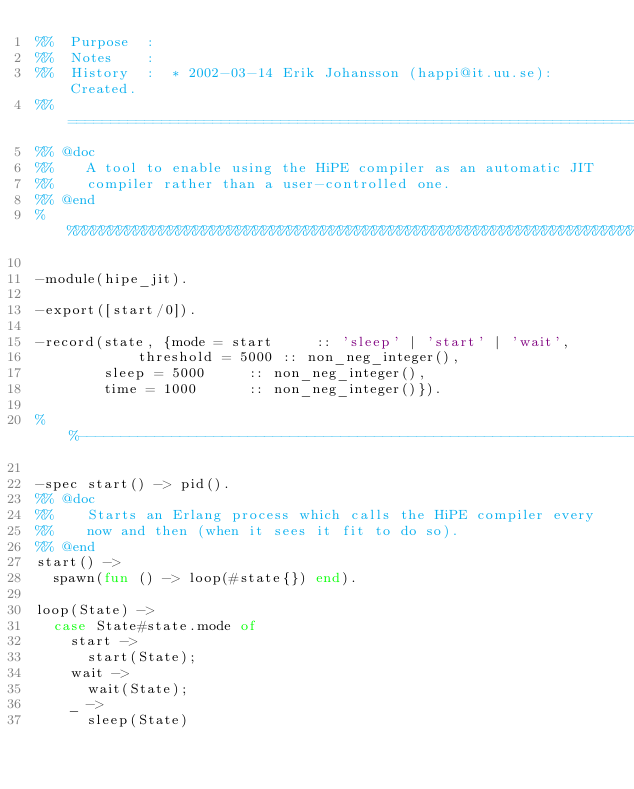<code> <loc_0><loc_0><loc_500><loc_500><_Erlang_>%%  Purpose  :  
%%  Notes    : 
%%  History  :	* 2002-03-14 Erik Johansson (happi@it.uu.se): Created.
%% ====================================================================
%% @doc
%%    A tool to enable using the HiPE compiler as an automatic JIT
%%    compiler rather than a user-controlled one.
%% @end
%%%%%%%%%%%%%%%%%%%%%%%%%%%%%%%%%%%%%%%%%%%%%%%%%%%%%%%%%%%%%%%%%%%%%%%

-module(hipe_jit).

-export([start/0]).

-record(state, {mode = start     :: 'sleep' | 'start' | 'wait',
	       	threshold = 5000 :: non_neg_integer(),
		sleep = 5000     :: non_neg_integer(),
		time = 1000      :: non_neg_integer()}).

%%---------------------------------------------------------------------

-spec start() -> pid().
%% @doc
%%    Starts an Erlang process which calls the HiPE compiler every
%%    now and then (when it sees it fit to do so).
%% @end
start() ->
  spawn(fun () -> loop(#state{}) end).

loop(State) ->
  case State#state.mode of
    start ->
      start(State);
    wait ->
      wait(State);
    _ ->
      sleep(State)</code> 